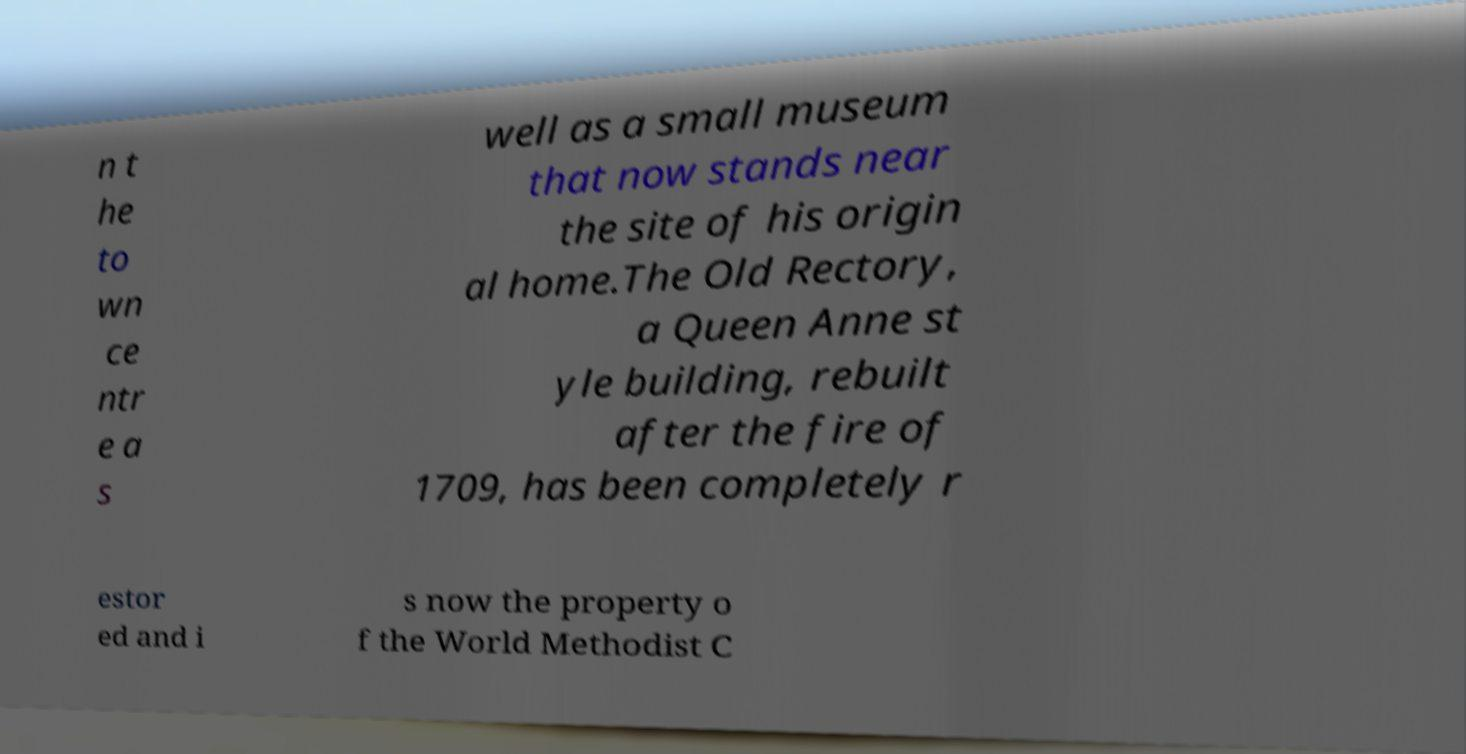What messages or text are displayed in this image? I need them in a readable, typed format. n t he to wn ce ntr e a s well as a small museum that now stands near the site of his origin al home.The Old Rectory, a Queen Anne st yle building, rebuilt after the fire of 1709, has been completely r estor ed and i s now the property o f the World Methodist C 